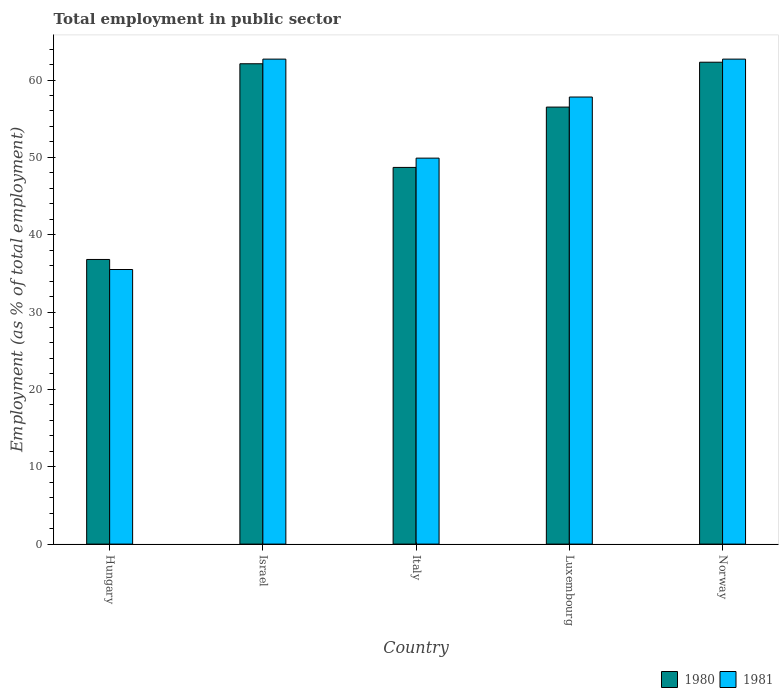How many different coloured bars are there?
Give a very brief answer. 2. How many groups of bars are there?
Give a very brief answer. 5. Are the number of bars on each tick of the X-axis equal?
Provide a succinct answer. Yes. How many bars are there on the 5th tick from the right?
Your answer should be very brief. 2. In how many cases, is the number of bars for a given country not equal to the number of legend labels?
Ensure brevity in your answer.  0. What is the employment in public sector in 1981 in Israel?
Give a very brief answer. 62.7. Across all countries, what is the maximum employment in public sector in 1981?
Make the answer very short. 62.7. Across all countries, what is the minimum employment in public sector in 1980?
Provide a succinct answer. 36.8. In which country was the employment in public sector in 1981 minimum?
Offer a terse response. Hungary. What is the total employment in public sector in 1981 in the graph?
Offer a very short reply. 268.6. What is the difference between the employment in public sector in 1980 in Israel and that in Luxembourg?
Your answer should be compact. 5.6. What is the difference between the employment in public sector in 1980 in Hungary and the employment in public sector in 1981 in Italy?
Provide a succinct answer. -13.1. What is the average employment in public sector in 1981 per country?
Provide a succinct answer. 53.72. What is the difference between the employment in public sector of/in 1981 and employment in public sector of/in 1980 in Luxembourg?
Ensure brevity in your answer.  1.3. In how many countries, is the employment in public sector in 1981 greater than 44 %?
Make the answer very short. 4. What is the ratio of the employment in public sector in 1980 in Israel to that in Italy?
Offer a terse response. 1.28. What is the difference between the highest and the second highest employment in public sector in 1980?
Give a very brief answer. 5.6. What is the difference between the highest and the lowest employment in public sector in 1980?
Offer a very short reply. 25.5. In how many countries, is the employment in public sector in 1980 greater than the average employment in public sector in 1980 taken over all countries?
Provide a succinct answer. 3. Is the sum of the employment in public sector in 1981 in Italy and Luxembourg greater than the maximum employment in public sector in 1980 across all countries?
Provide a short and direct response. Yes. How many bars are there?
Provide a succinct answer. 10. Are all the bars in the graph horizontal?
Provide a succinct answer. No. How many countries are there in the graph?
Your response must be concise. 5. What is the difference between two consecutive major ticks on the Y-axis?
Your response must be concise. 10. Does the graph contain any zero values?
Offer a terse response. No. Where does the legend appear in the graph?
Provide a succinct answer. Bottom right. How many legend labels are there?
Give a very brief answer. 2. What is the title of the graph?
Offer a terse response. Total employment in public sector. Does "1984" appear as one of the legend labels in the graph?
Offer a very short reply. No. What is the label or title of the Y-axis?
Give a very brief answer. Employment (as % of total employment). What is the Employment (as % of total employment) in 1980 in Hungary?
Give a very brief answer. 36.8. What is the Employment (as % of total employment) of 1981 in Hungary?
Make the answer very short. 35.5. What is the Employment (as % of total employment) of 1980 in Israel?
Provide a short and direct response. 62.1. What is the Employment (as % of total employment) in 1981 in Israel?
Keep it short and to the point. 62.7. What is the Employment (as % of total employment) of 1980 in Italy?
Offer a terse response. 48.7. What is the Employment (as % of total employment) in 1981 in Italy?
Provide a short and direct response. 49.9. What is the Employment (as % of total employment) in 1980 in Luxembourg?
Keep it short and to the point. 56.5. What is the Employment (as % of total employment) of 1981 in Luxembourg?
Ensure brevity in your answer.  57.8. What is the Employment (as % of total employment) of 1980 in Norway?
Offer a terse response. 62.3. What is the Employment (as % of total employment) of 1981 in Norway?
Ensure brevity in your answer.  62.7. Across all countries, what is the maximum Employment (as % of total employment) of 1980?
Give a very brief answer. 62.3. Across all countries, what is the maximum Employment (as % of total employment) of 1981?
Make the answer very short. 62.7. Across all countries, what is the minimum Employment (as % of total employment) of 1980?
Provide a succinct answer. 36.8. Across all countries, what is the minimum Employment (as % of total employment) of 1981?
Provide a succinct answer. 35.5. What is the total Employment (as % of total employment) in 1980 in the graph?
Your answer should be very brief. 266.4. What is the total Employment (as % of total employment) in 1981 in the graph?
Offer a very short reply. 268.6. What is the difference between the Employment (as % of total employment) of 1980 in Hungary and that in Israel?
Give a very brief answer. -25.3. What is the difference between the Employment (as % of total employment) of 1981 in Hungary and that in Israel?
Give a very brief answer. -27.2. What is the difference between the Employment (as % of total employment) of 1980 in Hungary and that in Italy?
Keep it short and to the point. -11.9. What is the difference between the Employment (as % of total employment) in 1981 in Hungary and that in Italy?
Your answer should be compact. -14.4. What is the difference between the Employment (as % of total employment) in 1980 in Hungary and that in Luxembourg?
Offer a very short reply. -19.7. What is the difference between the Employment (as % of total employment) in 1981 in Hungary and that in Luxembourg?
Keep it short and to the point. -22.3. What is the difference between the Employment (as % of total employment) of 1980 in Hungary and that in Norway?
Give a very brief answer. -25.5. What is the difference between the Employment (as % of total employment) of 1981 in Hungary and that in Norway?
Your answer should be compact. -27.2. What is the difference between the Employment (as % of total employment) in 1981 in Israel and that in Luxembourg?
Offer a terse response. 4.9. What is the difference between the Employment (as % of total employment) of 1981 in Israel and that in Norway?
Offer a terse response. 0. What is the difference between the Employment (as % of total employment) of 1981 in Italy and that in Luxembourg?
Your answer should be very brief. -7.9. What is the difference between the Employment (as % of total employment) in 1981 in Italy and that in Norway?
Your answer should be very brief. -12.8. What is the difference between the Employment (as % of total employment) in 1980 in Luxembourg and that in Norway?
Offer a very short reply. -5.8. What is the difference between the Employment (as % of total employment) in 1980 in Hungary and the Employment (as % of total employment) in 1981 in Israel?
Keep it short and to the point. -25.9. What is the difference between the Employment (as % of total employment) in 1980 in Hungary and the Employment (as % of total employment) in 1981 in Italy?
Your response must be concise. -13.1. What is the difference between the Employment (as % of total employment) in 1980 in Hungary and the Employment (as % of total employment) in 1981 in Norway?
Your answer should be compact. -25.9. What is the difference between the Employment (as % of total employment) in 1980 in Israel and the Employment (as % of total employment) in 1981 in Italy?
Give a very brief answer. 12.2. What is the difference between the Employment (as % of total employment) of 1980 in Israel and the Employment (as % of total employment) of 1981 in Luxembourg?
Provide a succinct answer. 4.3. What is the difference between the Employment (as % of total employment) of 1980 in Italy and the Employment (as % of total employment) of 1981 in Norway?
Your answer should be compact. -14. What is the average Employment (as % of total employment) of 1980 per country?
Your answer should be very brief. 53.28. What is the average Employment (as % of total employment) in 1981 per country?
Your answer should be very brief. 53.72. What is the difference between the Employment (as % of total employment) of 1980 and Employment (as % of total employment) of 1981 in Hungary?
Your answer should be very brief. 1.3. What is the difference between the Employment (as % of total employment) in 1980 and Employment (as % of total employment) in 1981 in Italy?
Your answer should be compact. -1.2. What is the difference between the Employment (as % of total employment) in 1980 and Employment (as % of total employment) in 1981 in Luxembourg?
Give a very brief answer. -1.3. What is the ratio of the Employment (as % of total employment) of 1980 in Hungary to that in Israel?
Keep it short and to the point. 0.59. What is the ratio of the Employment (as % of total employment) of 1981 in Hungary to that in Israel?
Provide a succinct answer. 0.57. What is the ratio of the Employment (as % of total employment) in 1980 in Hungary to that in Italy?
Ensure brevity in your answer.  0.76. What is the ratio of the Employment (as % of total employment) in 1981 in Hungary to that in Italy?
Ensure brevity in your answer.  0.71. What is the ratio of the Employment (as % of total employment) in 1980 in Hungary to that in Luxembourg?
Your response must be concise. 0.65. What is the ratio of the Employment (as % of total employment) in 1981 in Hungary to that in Luxembourg?
Offer a terse response. 0.61. What is the ratio of the Employment (as % of total employment) of 1980 in Hungary to that in Norway?
Offer a terse response. 0.59. What is the ratio of the Employment (as % of total employment) in 1981 in Hungary to that in Norway?
Give a very brief answer. 0.57. What is the ratio of the Employment (as % of total employment) of 1980 in Israel to that in Italy?
Offer a very short reply. 1.28. What is the ratio of the Employment (as % of total employment) of 1981 in Israel to that in Italy?
Your answer should be compact. 1.26. What is the ratio of the Employment (as % of total employment) of 1980 in Israel to that in Luxembourg?
Provide a short and direct response. 1.1. What is the ratio of the Employment (as % of total employment) in 1981 in Israel to that in Luxembourg?
Ensure brevity in your answer.  1.08. What is the ratio of the Employment (as % of total employment) of 1981 in Israel to that in Norway?
Provide a succinct answer. 1. What is the ratio of the Employment (as % of total employment) in 1980 in Italy to that in Luxembourg?
Offer a very short reply. 0.86. What is the ratio of the Employment (as % of total employment) in 1981 in Italy to that in Luxembourg?
Provide a short and direct response. 0.86. What is the ratio of the Employment (as % of total employment) in 1980 in Italy to that in Norway?
Provide a succinct answer. 0.78. What is the ratio of the Employment (as % of total employment) of 1981 in Italy to that in Norway?
Provide a succinct answer. 0.8. What is the ratio of the Employment (as % of total employment) of 1980 in Luxembourg to that in Norway?
Your response must be concise. 0.91. What is the ratio of the Employment (as % of total employment) in 1981 in Luxembourg to that in Norway?
Keep it short and to the point. 0.92. What is the difference between the highest and the lowest Employment (as % of total employment) of 1981?
Provide a short and direct response. 27.2. 